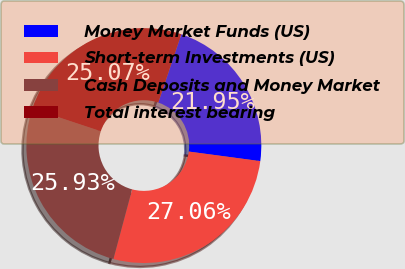<chart> <loc_0><loc_0><loc_500><loc_500><pie_chart><fcel>Money Market Funds (US)<fcel>Short-term Investments (US)<fcel>Cash Deposits and Money Market<fcel>Total interest bearing<nl><fcel>21.95%<fcel>27.06%<fcel>25.93%<fcel>25.07%<nl></chart> 